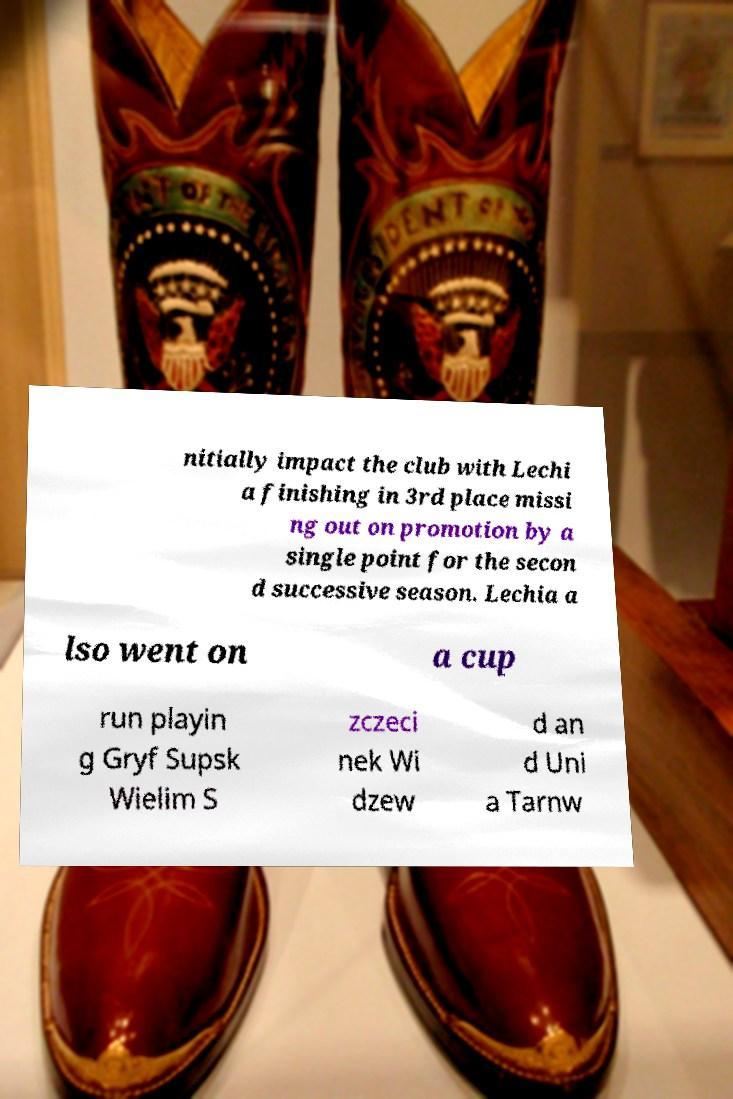I need the written content from this picture converted into text. Can you do that? nitially impact the club with Lechi a finishing in 3rd place missi ng out on promotion by a single point for the secon d successive season. Lechia a lso went on a cup run playin g Gryf Supsk Wielim S zczeci nek Wi dzew d an d Uni a Tarnw 